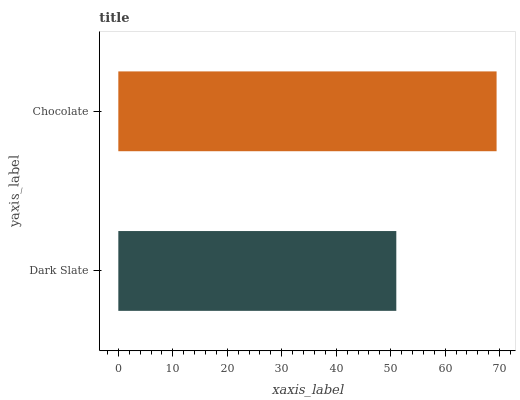Is Dark Slate the minimum?
Answer yes or no. Yes. Is Chocolate the maximum?
Answer yes or no. Yes. Is Chocolate the minimum?
Answer yes or no. No. Is Chocolate greater than Dark Slate?
Answer yes or no. Yes. Is Dark Slate less than Chocolate?
Answer yes or no. Yes. Is Dark Slate greater than Chocolate?
Answer yes or no. No. Is Chocolate less than Dark Slate?
Answer yes or no. No. Is Chocolate the high median?
Answer yes or no. Yes. Is Dark Slate the low median?
Answer yes or no. Yes. Is Dark Slate the high median?
Answer yes or no. No. Is Chocolate the low median?
Answer yes or no. No. 